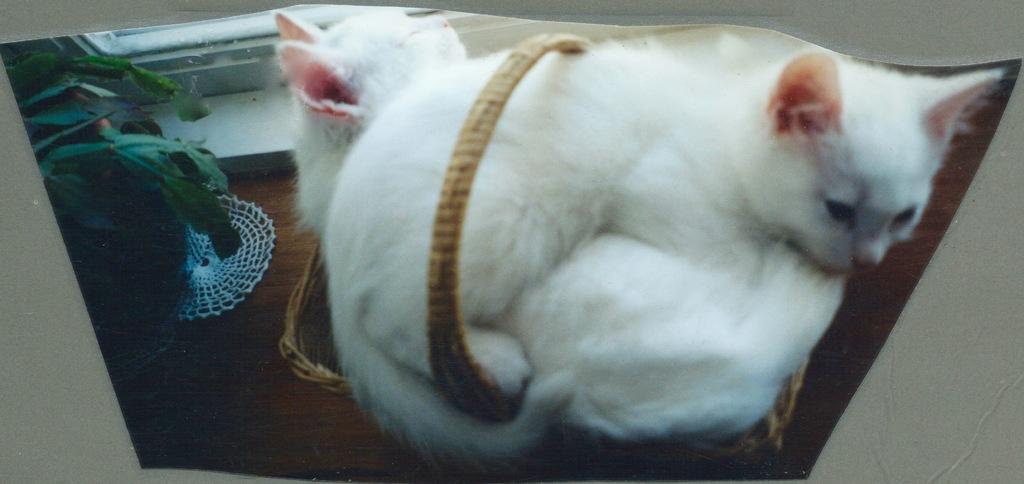In one or two sentences, can you explain what this image depicts? In this picture we can see the pictures of cats seems to be sitting in the wooden basket. On the left we can see the picture of a house plant and the pictures of some other objects. In the background we can see some object seems to be the wall. 